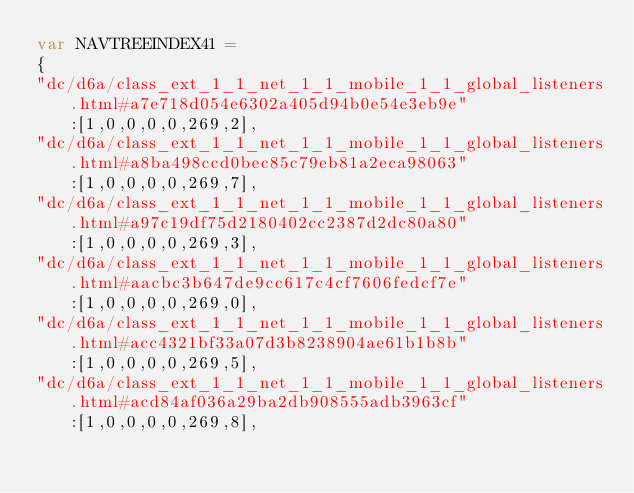<code> <loc_0><loc_0><loc_500><loc_500><_JavaScript_>var NAVTREEINDEX41 =
{
"dc/d6a/class_ext_1_1_net_1_1_mobile_1_1_global_listeners.html#a7e718d054e6302a405d94b0e54e3eb9e":[1,0,0,0,0,269,2],
"dc/d6a/class_ext_1_1_net_1_1_mobile_1_1_global_listeners.html#a8ba498ccd0bec85c79eb81a2eca98063":[1,0,0,0,0,269,7],
"dc/d6a/class_ext_1_1_net_1_1_mobile_1_1_global_listeners.html#a97c19df75d2180402cc2387d2dc80a80":[1,0,0,0,0,269,3],
"dc/d6a/class_ext_1_1_net_1_1_mobile_1_1_global_listeners.html#aacbc3b647de9cc617c4cf7606fedcf7e":[1,0,0,0,0,269,0],
"dc/d6a/class_ext_1_1_net_1_1_mobile_1_1_global_listeners.html#acc4321bf33a07d3b8238904ae61b1b8b":[1,0,0,0,0,269,5],
"dc/d6a/class_ext_1_1_net_1_1_mobile_1_1_global_listeners.html#acd84af036a29ba2db908555adb3963cf":[1,0,0,0,0,269,8],</code> 